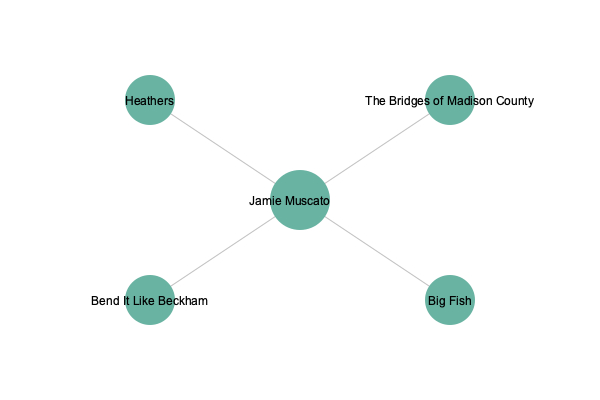Based on the network graph of Jamie Muscato's career in musical theatre, which production represents his breakthrough role as JD, showcasing his ability to portray complex, morally ambiguous characters? To answer this question, we need to analyze Jamie Muscato's career trajectory as represented in the network graph:

1. The graph shows Jamie Muscato at the center, connected to four major productions.

2. These productions are:
   - Heathers
   - The Bridges of Madison County
   - Bend It Like Beckham
   - Big Fish

3. Among these productions, "Heathers" is known for its complex, morally ambiguous characters, particularly the role of JD.

4. Jamie Muscato's portrayal of JD in "Heathers" was indeed his breakthrough role, garnering critical acclaim and showcasing his ability to handle complex characters.

5. The other productions, while significant in his career, did not provide the same level of character complexity or career-defining moment as "Heathers" did.

6. "Heathers" is positioned at the top left of the graph, possibly indicating its importance in Jamie's career trajectory.

Therefore, based on the information provided in the network graph and our knowledge of Jamie Muscato's career, the production that represents his breakthrough role as JD, showcasing his ability to portray complex, morally ambiguous characters, is "Heathers."
Answer: Heathers 